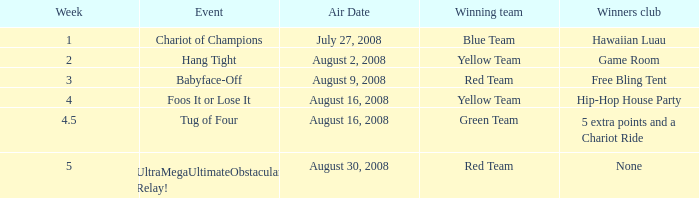For which week is the air date august 30, 2008? 5.0. 